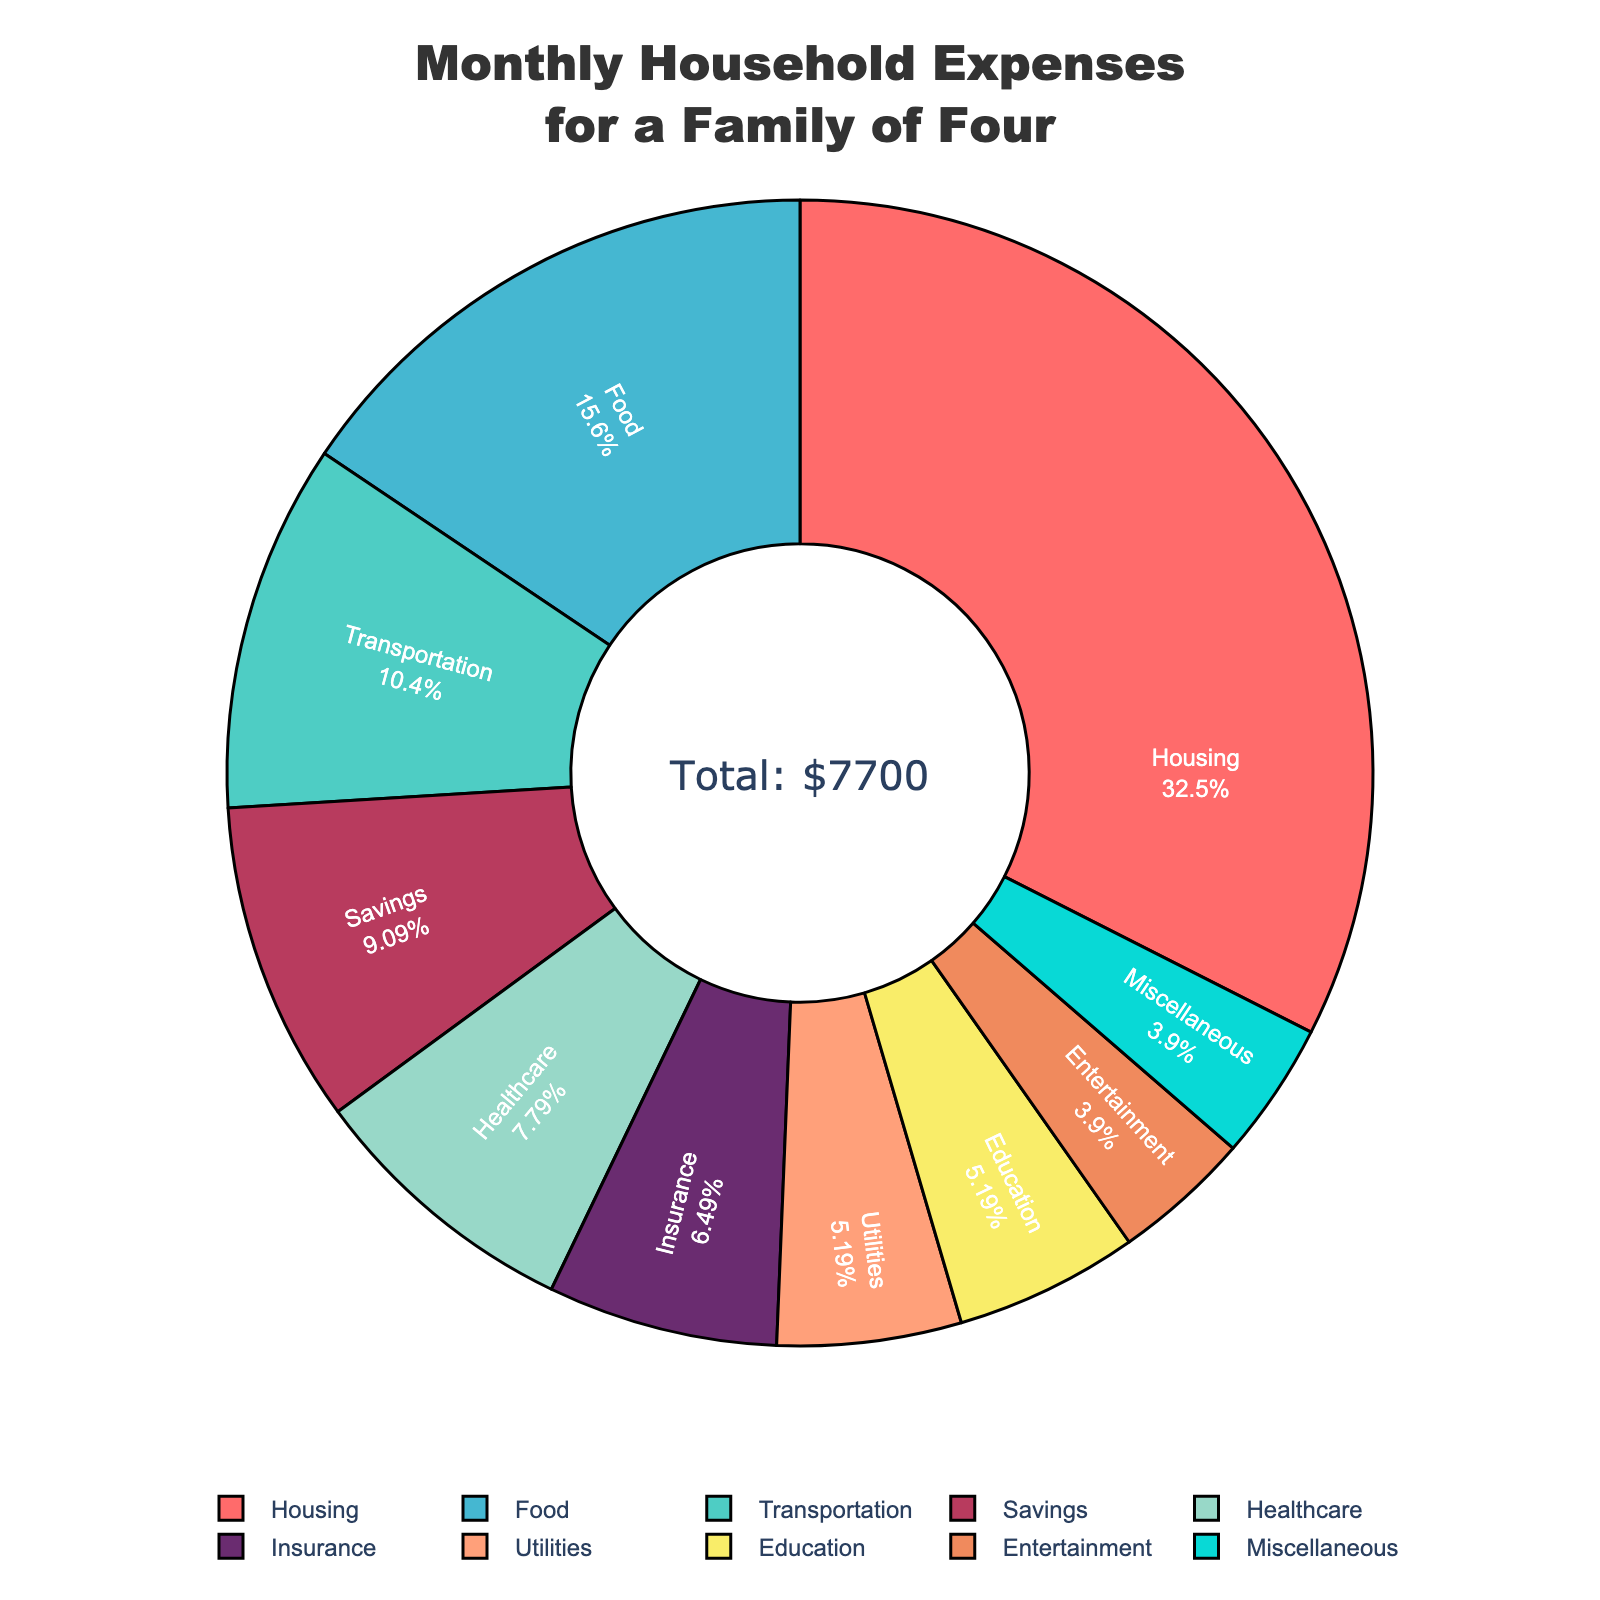What is the title of the figure? The title is positioned at the top center of the figure and clearly describes the content of the pie chart.
Answer: "Monthly Household Expenses for a Family of Four" Which expense category has the largest allocation? Look at the pie chart and identify the largest slice; it also displays the categories and their corresponding percentages.
Answer: Housing How much is spent on Transportation monthly? Refer to the labeled slices in the pie chart to find the Transportation slice and its value.
Answer: $800 What percentage of the total monthly expenses is allocated to Healthcare? Check the pie chart slices and identify the one labeled Healthcare along with its percentage information.
Answer: 10% Add up the expenses for Food, Housing, and Transportation. What do you get? Sum the values for Food ($1200), Housing ($2500), and Transportation ($800) as provided in the pie chart.
Answer: $4500 Which category has a higher percentage: Education or Entertainment? Compare the slices labeled Education and Entertainment and check their respective percentages.
Answer: Education How much more is allocated to Savings compared to Miscellaneous? Subtract the Miscellaneous expense ($300) from the Savings expense ($700).
Answer: $400 If the total monthly expense is $8,700, what is the average monthly expense per category? The total expense is divided by the number of categories (10): $8,700 / 10.
Answer: $870 Is the percentage of the Utilities category greater than 5%? Check the slice labeled Utilities and look at its percentage value.
Answer: No What is the combined percentage of Housing and Food expenses? Add the percentages of the Housing and Food slices as indicated on the pie chart.
Answer: 42.5% 